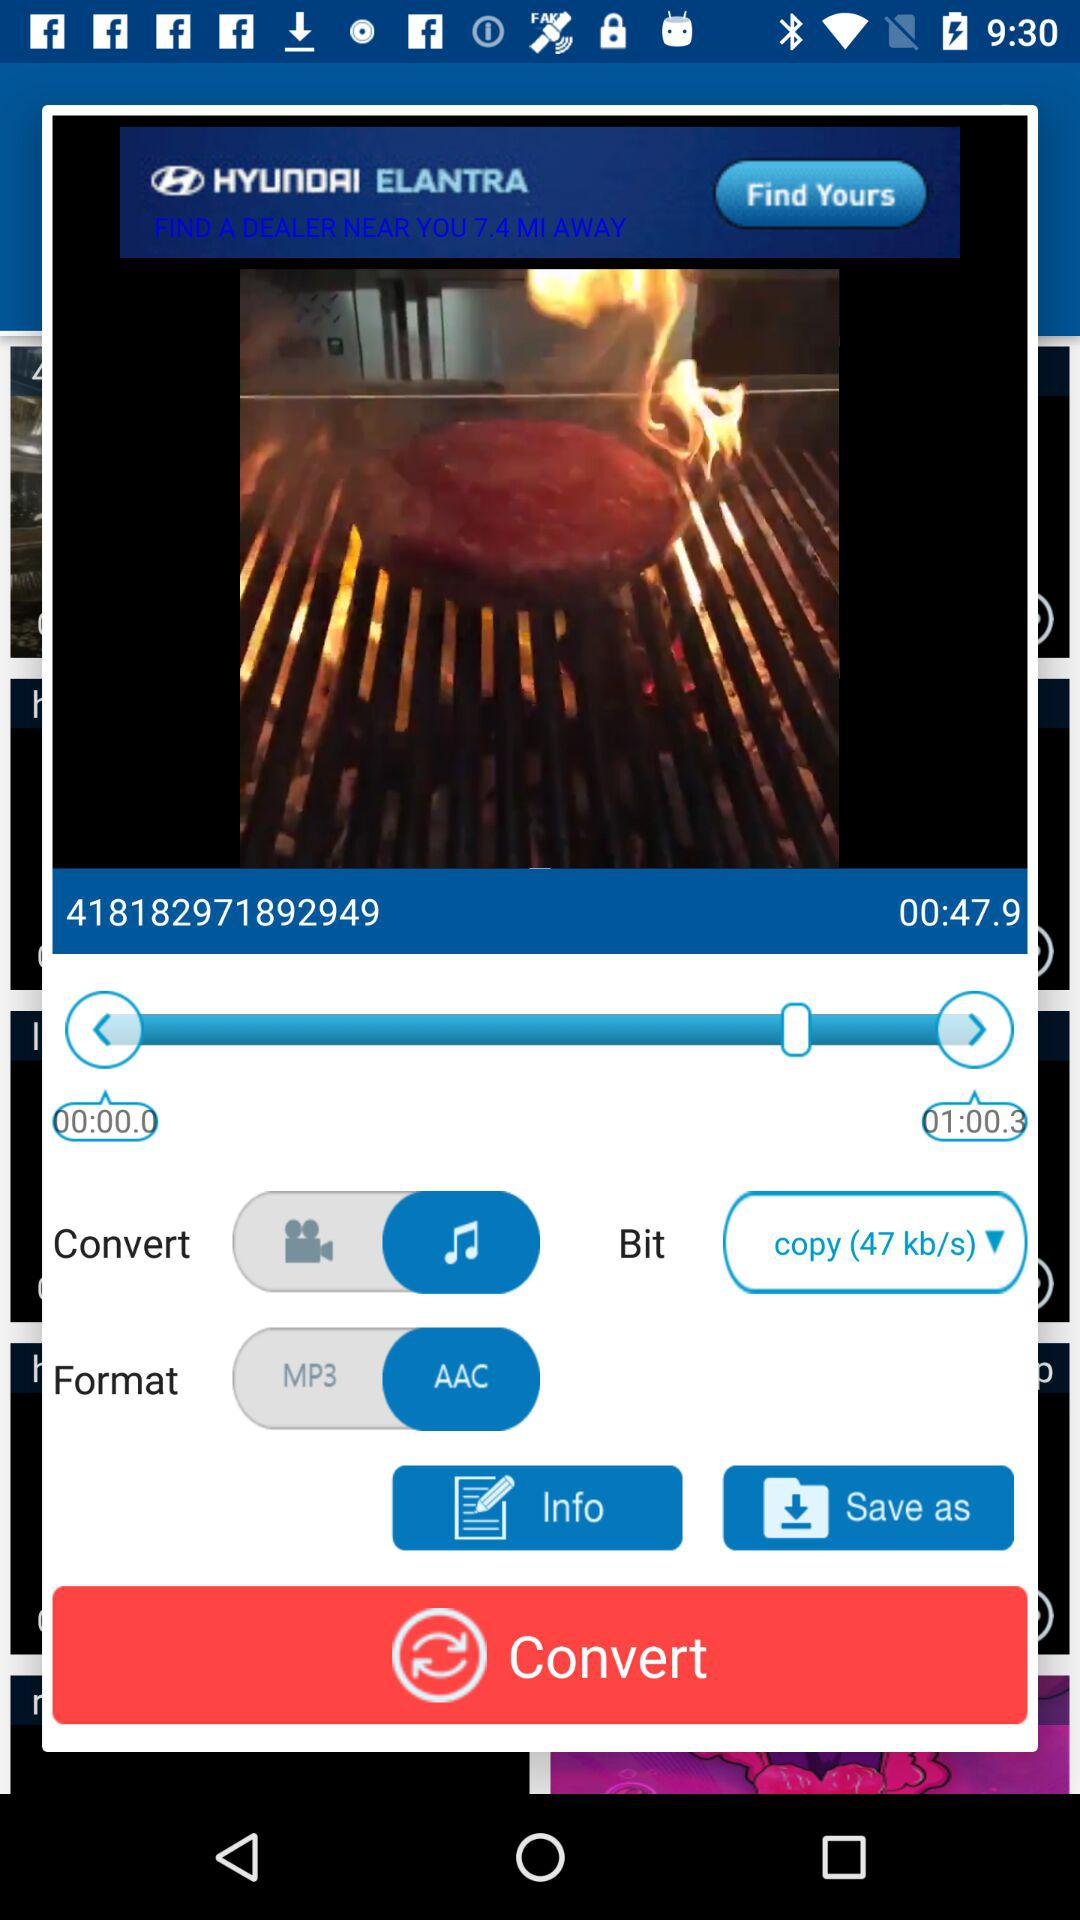How many seconds after 00:00:0 is 00:47.9?
Answer the question using a single word or phrase. 47.9 